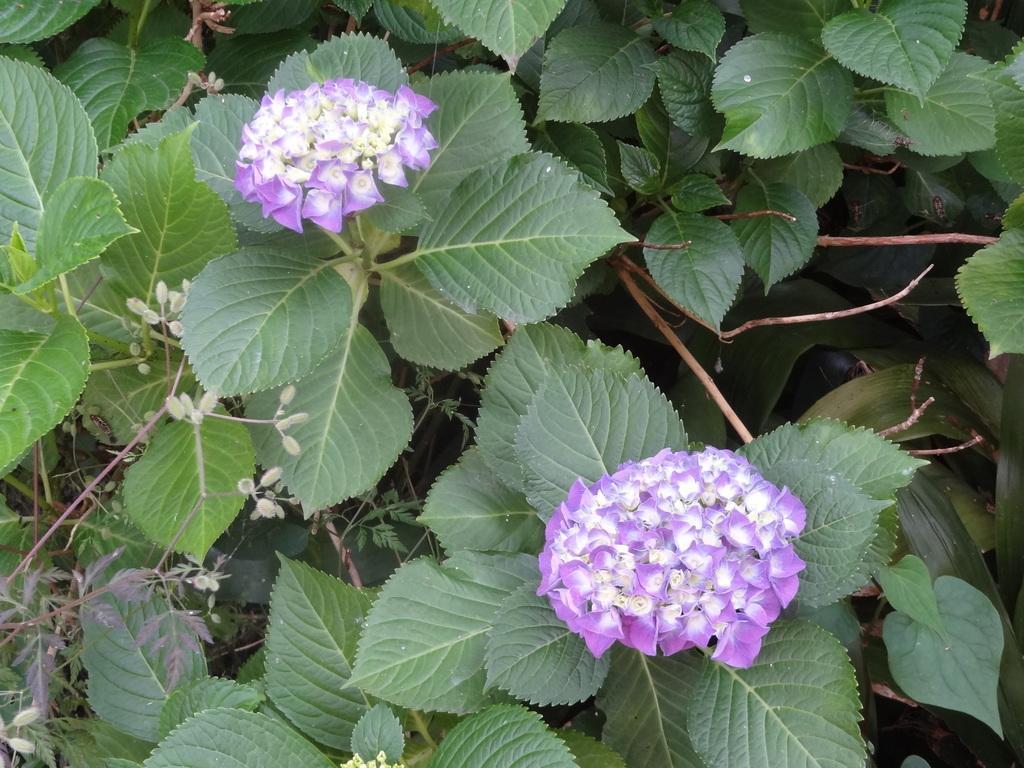Describe this image in one or two sentences. In the picture I can see flower plants. These flowers are purple in color. 